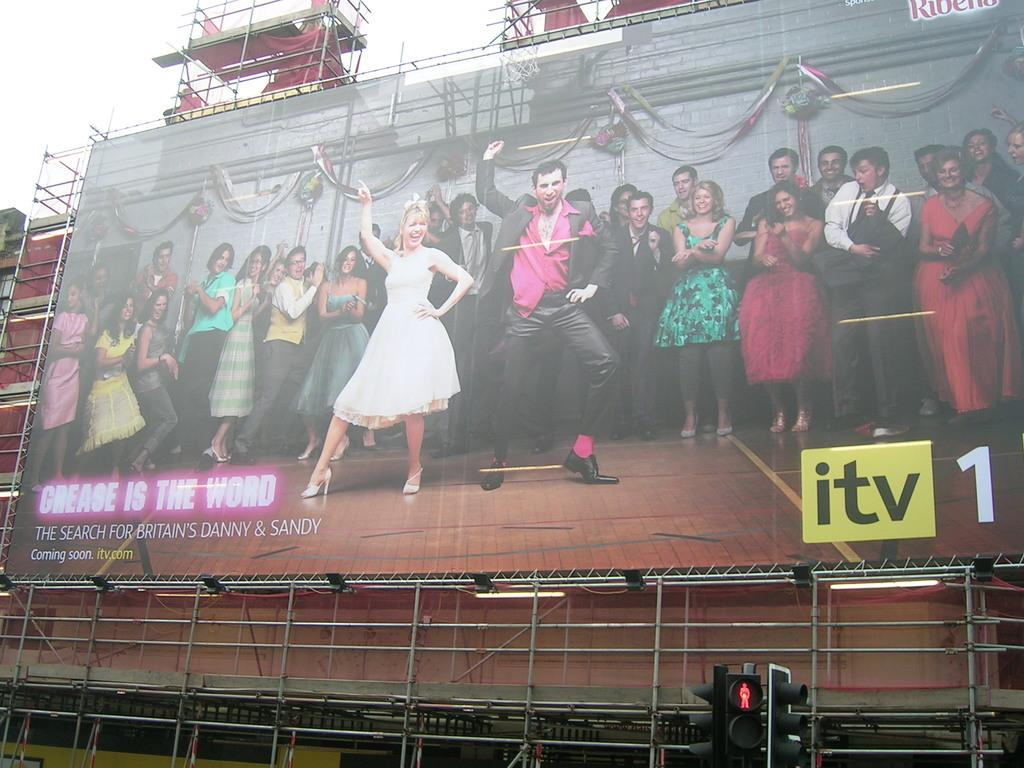<image>
Write a terse but informative summary of the picture. A large hoarding shows two people dancing as a large group watch in an advert for an ITV 1 TV show called Grease is the Word 